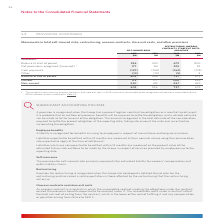According to Woolworths Limited's financial document, When is provision for restructuring recognised? Provision for restructuring is recognised when the Group has developed a detailed formal plan for the restructuring and has raised a valid expectation in those affected by the restructuring that the restructuring will occur.. The document states: "Provision for restructuring is recognised when the Group has developed a detailed formal plan for the restructuring and has raised a valid expectation..." Also, What is the amount of current self-insured risks in 2019? According to the financial document, 173 (in millions). The relevant text states: "Balance at end of period 603 596 737 679 Current 173 177 280 256 Non‑current 430 419 457 423 603 596 737 679..." Also, What is the units used in the table? According to the financial document, $M. The relevant text states: "2019 $M 2018 $M 2019 $M 2018 $M..." Also, can you calculate: What is the nominal difference of non-current self-insured risks between 2019 and 2018? Based on the calculation: 430 - 419 , the result is 11 (in millions). This is based on the information: "3 596 737 679 Current 173 177 280 256 Non‑current 430 419 457 423 603 596 737 679 6 737 679 Current 173 177 280 256 Non‑current 430 419 457 423 603 596 737 679..." The key data points involved are: 419, 430. Also, can you calculate: What is the percentage constitution of current self-insured risks in the total self-insured risks in 2019? Based on the calculation: 173/603 , the result is 28.69 (percentage). This is based on the information: "8) Other (13) (10) (5) 2 Balance at end of period 603 596 737 679 Current 173 177 280 256 Non‑current 430 419 457 423 603 596 737 679 Balance at end of period 603 596 737 679 Current 173 177 280 256 N..." The key data points involved are: 173, 603. Also, can you calculate: What is the average cash payments for self-insured risks for both years? To answer this question, I need to perform calculations using the financial data. The calculation is: (157 + 148)/2 , which equals 152.5 (in millions). This is based on the information: "/(reversed) 1 177 161 225 55 Cash payments (157) (148) (162) (178) Other (13) (10) (5) 2 Balance at end of period 603 596 737 679 Current 173 177 280 256 gnised/(reversed) 1 177 161 225 55 Cash paymen..." The key data points involved are: 148, 157. 